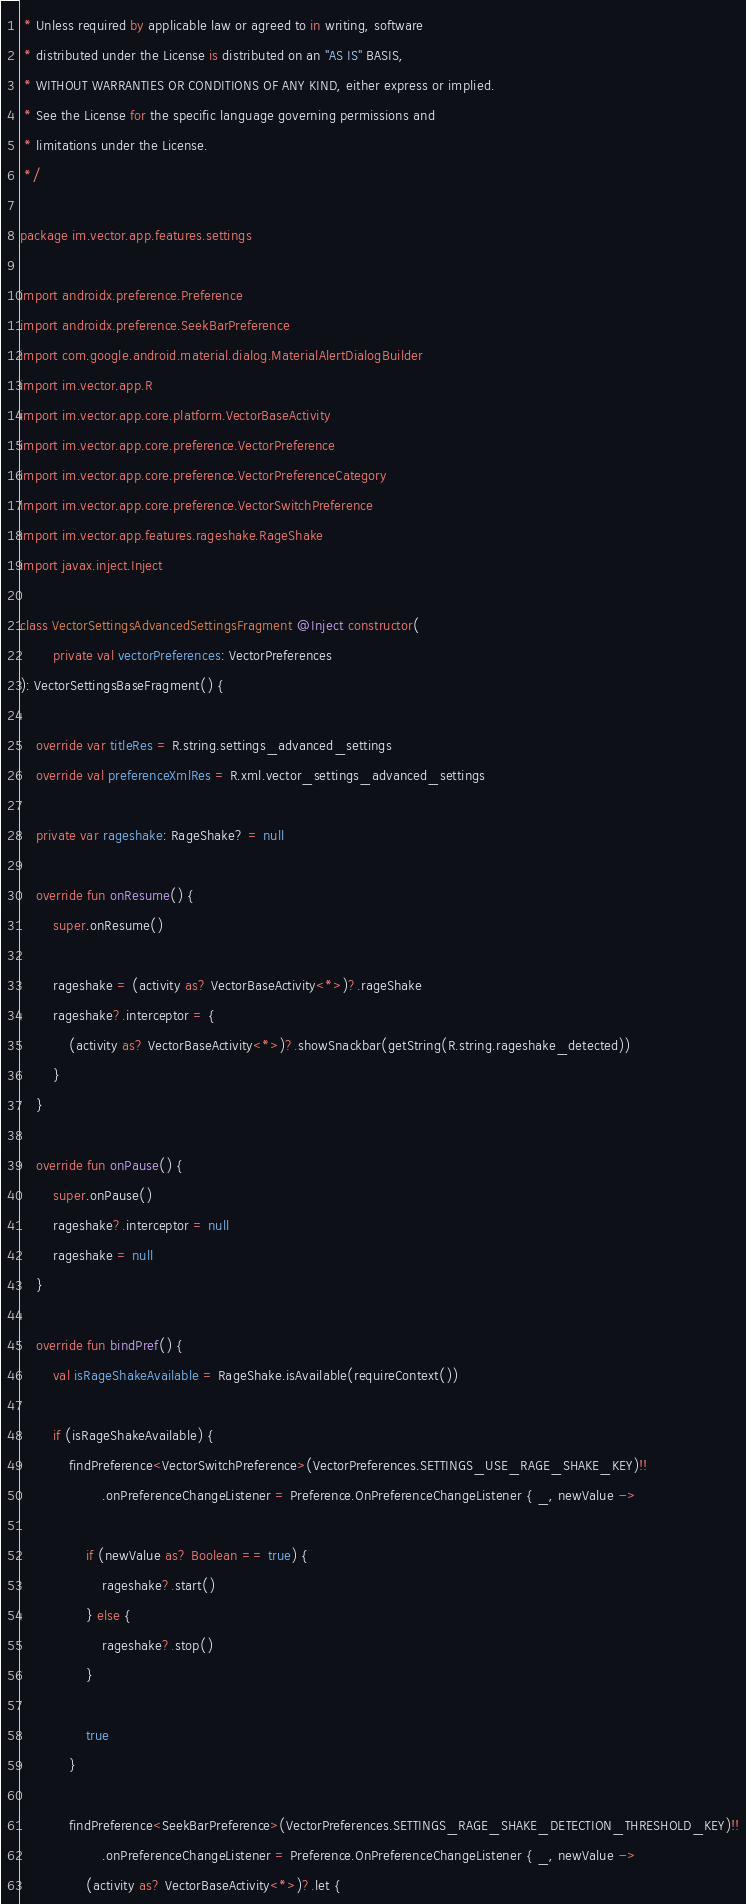<code> <loc_0><loc_0><loc_500><loc_500><_Kotlin_> * Unless required by applicable law or agreed to in writing, software
 * distributed under the License is distributed on an "AS IS" BASIS,
 * WITHOUT WARRANTIES OR CONDITIONS OF ANY KIND, either express or implied.
 * See the License for the specific language governing permissions and
 * limitations under the License.
 */

package im.vector.app.features.settings

import androidx.preference.Preference
import androidx.preference.SeekBarPreference
import com.google.android.material.dialog.MaterialAlertDialogBuilder
import im.vector.app.R
import im.vector.app.core.platform.VectorBaseActivity
import im.vector.app.core.preference.VectorPreference
import im.vector.app.core.preference.VectorPreferenceCategory
import im.vector.app.core.preference.VectorSwitchPreference
import im.vector.app.features.rageshake.RageShake
import javax.inject.Inject

class VectorSettingsAdvancedSettingsFragment @Inject constructor(
        private val vectorPreferences: VectorPreferences
): VectorSettingsBaseFragment() {

    override var titleRes = R.string.settings_advanced_settings
    override val preferenceXmlRes = R.xml.vector_settings_advanced_settings

    private var rageshake: RageShake? = null

    override fun onResume() {
        super.onResume()

        rageshake = (activity as? VectorBaseActivity<*>)?.rageShake
        rageshake?.interceptor = {
            (activity as? VectorBaseActivity<*>)?.showSnackbar(getString(R.string.rageshake_detected))
        }
    }

    override fun onPause() {
        super.onPause()
        rageshake?.interceptor = null
        rageshake = null
    }

    override fun bindPref() {
        val isRageShakeAvailable = RageShake.isAvailable(requireContext())

        if (isRageShakeAvailable) {
            findPreference<VectorSwitchPreference>(VectorPreferences.SETTINGS_USE_RAGE_SHAKE_KEY)!!
                    .onPreferenceChangeListener = Preference.OnPreferenceChangeListener { _, newValue ->

                if (newValue as? Boolean == true) {
                    rageshake?.start()
                } else {
                    rageshake?.stop()
                }

                true
            }

            findPreference<SeekBarPreference>(VectorPreferences.SETTINGS_RAGE_SHAKE_DETECTION_THRESHOLD_KEY)!!
                    .onPreferenceChangeListener = Preference.OnPreferenceChangeListener { _, newValue ->
                (activity as? VectorBaseActivity<*>)?.let {</code> 